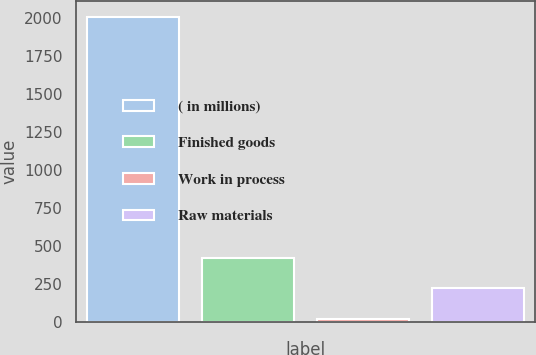Convert chart. <chart><loc_0><loc_0><loc_500><loc_500><bar_chart><fcel>( in millions)<fcel>Finished goods<fcel>Work in process<fcel>Raw materials<nl><fcel>2010<fcel>419.12<fcel>21.4<fcel>220.26<nl></chart> 